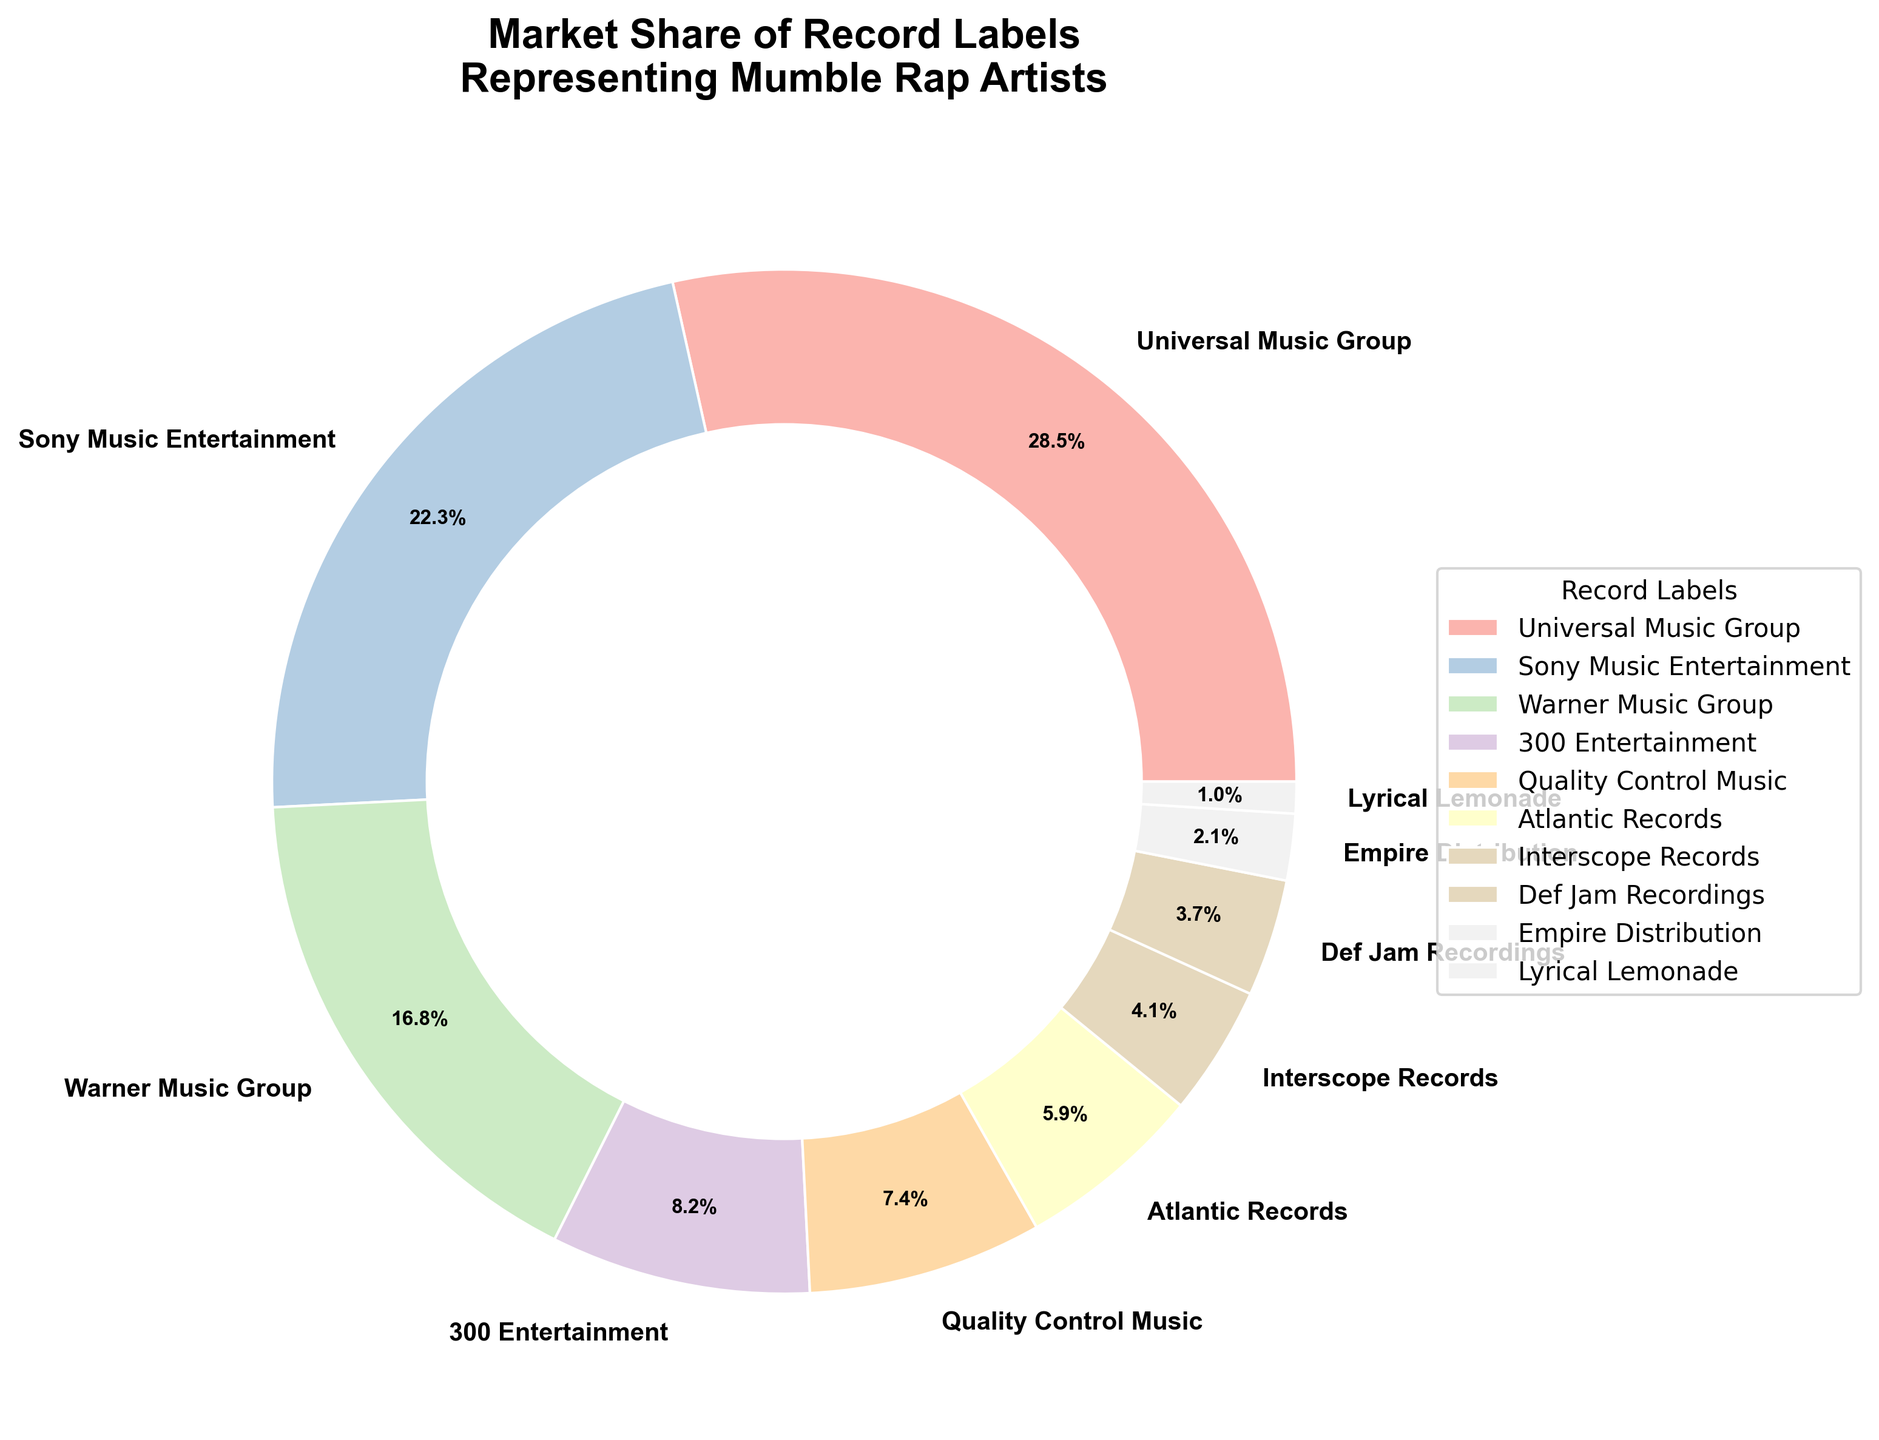What percentage of the market is shared by Universal Music Group and Sony Music Entertainment combined? To find the combined market share of Universal Music Group and Sony Music Entertainment, simply add their individual shares: 28.5 (Universal Music Group) + 22.3 (Sony Music Entertainment) = 50.8.
Answer: 50.8% Which record label has a larger market share, Warner Music Group or Quality Control Music? Warner Music Group's market share is 16.8% while Quality Control Music's market share is 7.4%. Comparing the two, Warner Music Group has a larger market share.
Answer: Warner Music Group What's the difference in market share between Atlantic Records and Def Jam Recordings? Subtract the market share of Def Jam Recordings (3.7%) from Atlantic Records (5.9%): 5.9 - 3.7 = 2.2.
Answer: 2.2% How many labels have a market share greater than 10%? By observing the chart, the labels with a market share greater than 10% are Universal Music Group (28.5%), Sony Music Entertainment (22.3%), and Warner Music Group (16.8%). So, there are 3 labels in total.
Answer: 3 Is the market share of Lyrical Lemonade smaller than that of Empire Distribution? Lyrical Lemonade's market share is 1.0%, while Empire Distribution's market share is 2.1%. Since 1.0% is less than 2.1%, Lyrical Lemonade's share is indeed smaller.
Answer: Yes What is the average market share of the top four record labels? Add the market shares of the top four labels: 28.5 (Universal Music Group) + 22.3 (Sony Music Entertainment) + 16.8 (Warner Music Group) + 8.2 (300 Entertainment) = 75.8. Then, divide by 4 to find the average: 75.8 / 4 ≈ 18.95.
Answer: 18.95% Rank the top three record labels in terms of market share in descending order. By examining the pie chart, the top three labels by market share are: 1) Universal Music Group (28.5%), 2) Sony Music Entertainment (22.3%), 3) Warner Music Group (16.8%).
Answer: Universal Music Group, Sony Music Entertainment, Warner Music Group How much of the market is controlled by the bottom three record labels combined? Sum the market shares of the bottom three labels: Def Jam Recordings (3.7%), Empire Distribution (2.1%), Lyrical Lemonade (1.0%) = 3.7 + 2.1 + 1.0 = 6.8.
Answer: 6.8% What is the median market share value among all listed labels? List out the market shares in ascending order: 1.0, 2.1, 3.7, 4.1, 5.9, 7.4, 8.2, 16.8, 22.3, 28.5. Since there are 10 values, the median is the average of the 5th and 6th values: (5.9 + 7.4) / 2 = 6.65.
Answer: 6.65 Which record label contributes the smallest market share and what is that percentage? By observing the pie chart, Lyrical Lemonade has the smallest market share, which is 1.0%.
Answer: Lyrical Lemonade, 1.0% 